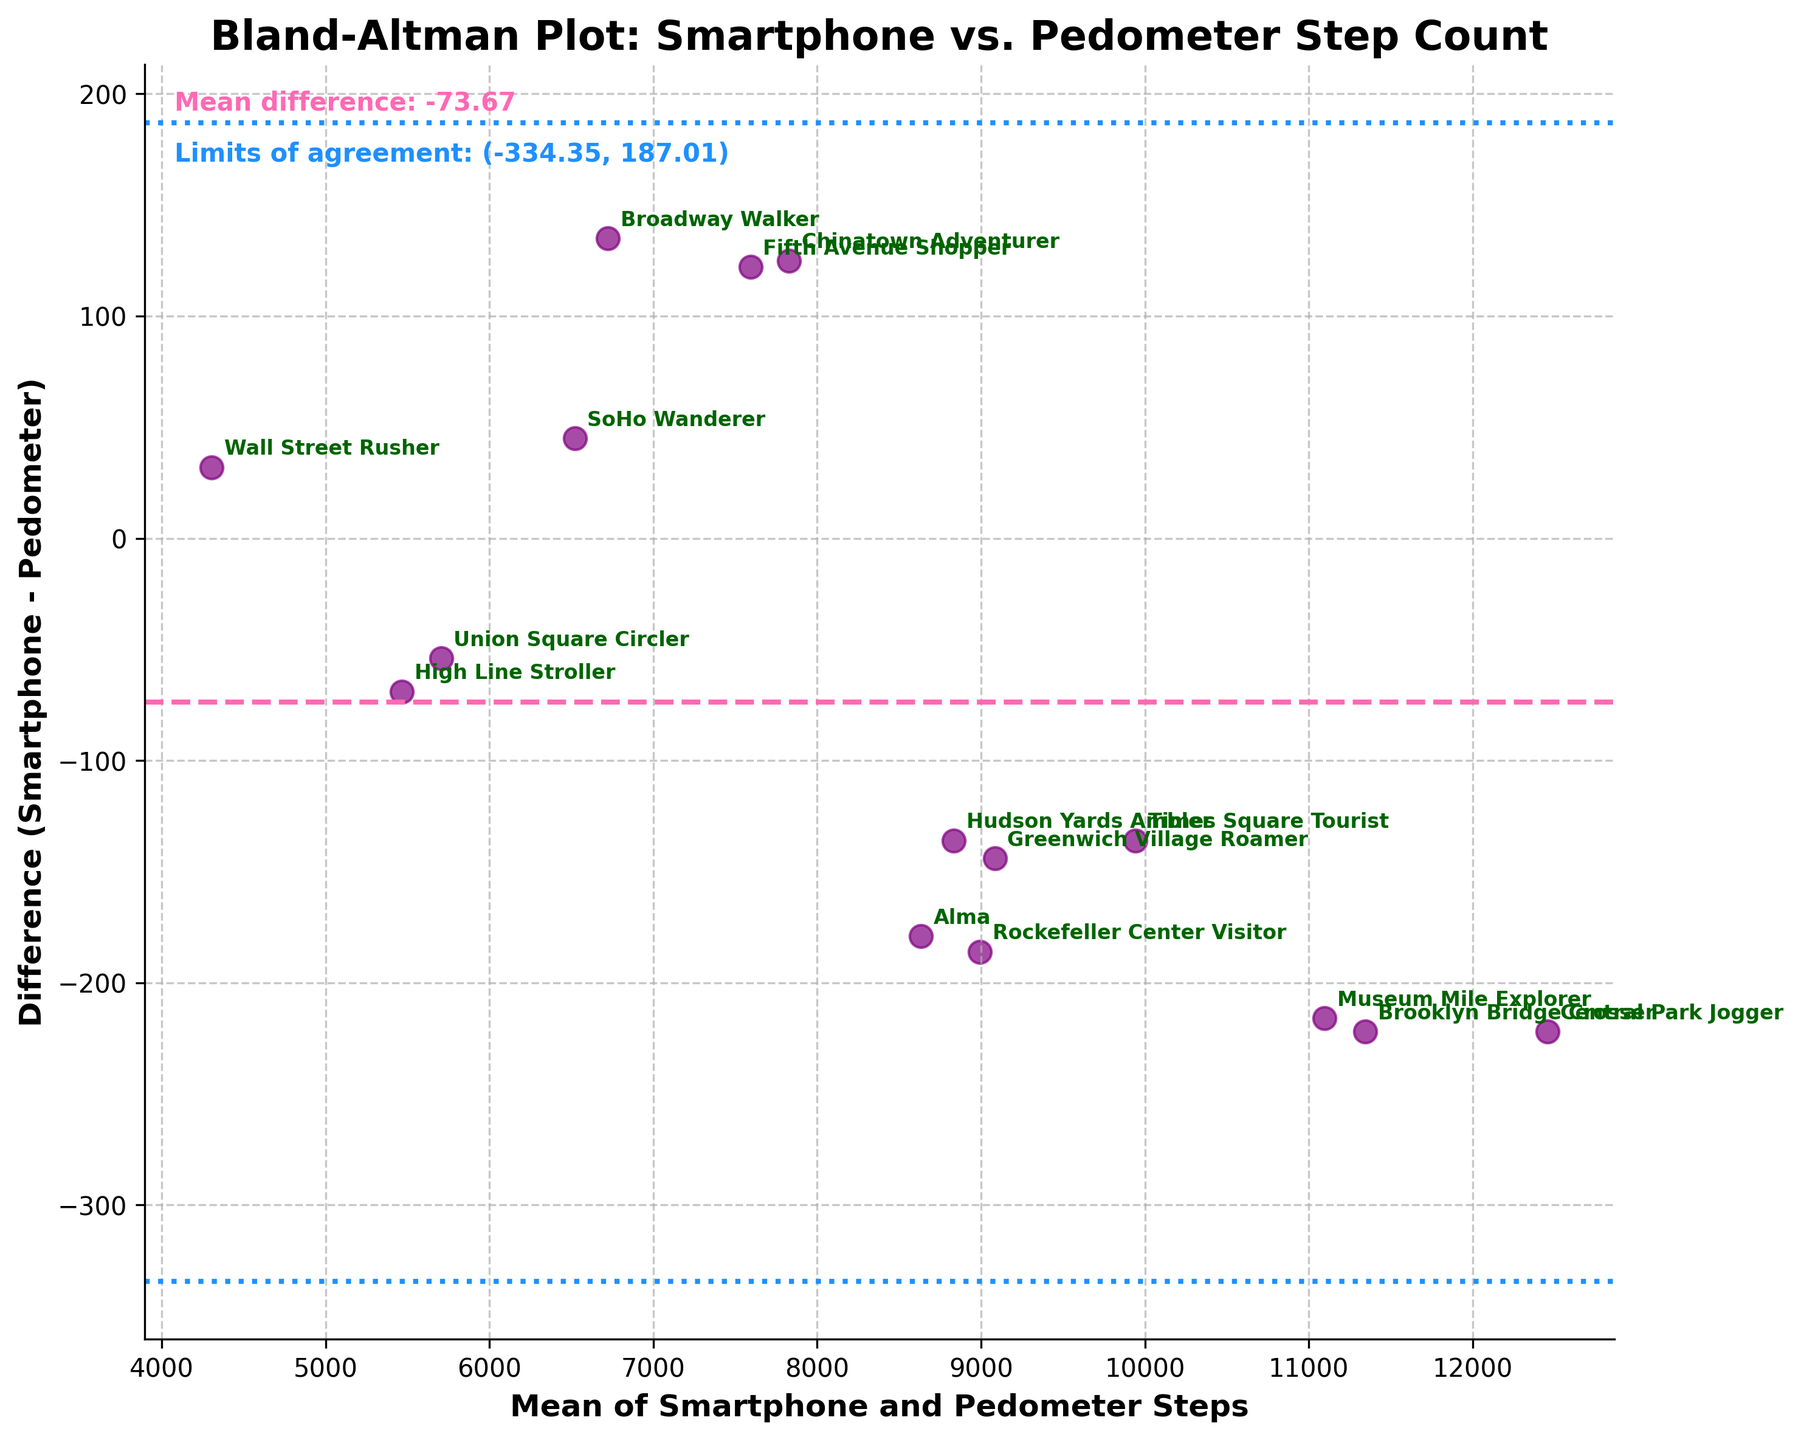What's the title of the plot? The title of the plot is found at the top of the figure. It reads, "Bland-Altman Plot: Smartphone vs. Pedometer Step Count."
Answer: Bland-Altman Plot: Smartphone vs. Pedometer Step Count What do the purple dots represent in the plot? Each purple dot on the plot represents a participant and shows the relationship between the mean number of steps taken (on the x-axis) and the difference in step counts between the smartphone app and pedometer (on the y-axis).
Answer: Participants' step data How many participants' data are shown in the plot? Count each purple dot on the plot to determine the number of participants. Ensure that each dot is unique and corresponds to a single participant.
Answer: 15 What is the mean difference between the smartphone and pedometer step counts? The mean difference is represented by the dashed pink horizontal line, and the exact value is displayed in the text box on the plot.
Answer: Approximately -40.80 What do the dashed blue lines represent? The dashed blue lines show the limits of agreement, indicating the range in which most differences between the smartphone and pedometer step counts are expected to fall.
Answer: Limits of agreement Which participants show the largest discrepancy between smartphone and pedometer step counts? Identify the points on the plot with the largest vertical distance from the mean difference line, then refer to annotations for the participant names.
Answer: Alma and Chinatown Adventurer For which participant do the steps measured by the smartphone most closely match the pedometer? Look for the dot closest to the horizontal line at 0 (no difference) on the plot to find the participant with the smallest difference.
Answer: Times Square Tourist What are the numerical values of the limits of agreement? The exact numerical values of the limits of agreement are found in the plot text box, calculated as mean ± 1.96 * standard deviation of differences.
Answer: Approximately (-343.88, 262.28) Is the mean difference positive or negative? Notice the position of the dashed pink line relative to 0 on the y-axis; if the line is below 0, the mean difference is negative.
Answer: Negative What is the difference in mean steps between the High Line Stroller and Fifth Avenue Shopper? Calculate the mean number of steps for both participants individually (mean of smartphone and pedometer steps), then find their difference.
Answer: (5466.5 for High Line Stroller vs. 7593 for Fifth Avenue Shopper), difference is -2126.5 